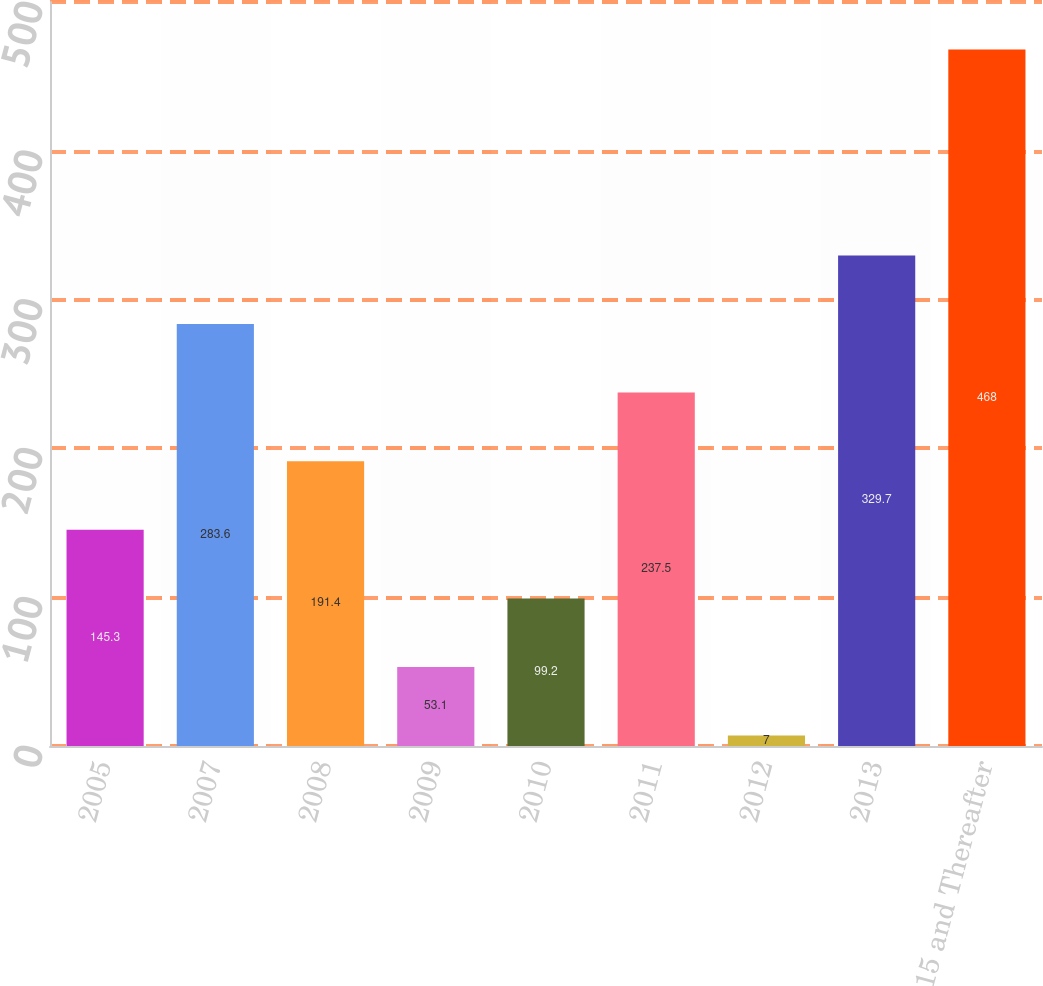Convert chart to OTSL. <chart><loc_0><loc_0><loc_500><loc_500><bar_chart><fcel>2005<fcel>2007<fcel>2008<fcel>2009<fcel>2010<fcel>2011<fcel>2012<fcel>2013<fcel>2015 and Thereafter<nl><fcel>145.3<fcel>283.6<fcel>191.4<fcel>53.1<fcel>99.2<fcel>237.5<fcel>7<fcel>329.7<fcel>468<nl></chart> 